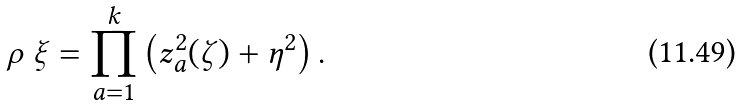Convert formula to latex. <formula><loc_0><loc_0><loc_500><loc_500>\rho \ \xi = \prod _ { a = 1 } ^ { k } \left ( z _ { a } ^ { 2 } ( \zeta ) + \eta ^ { 2 } \right ) .</formula> 